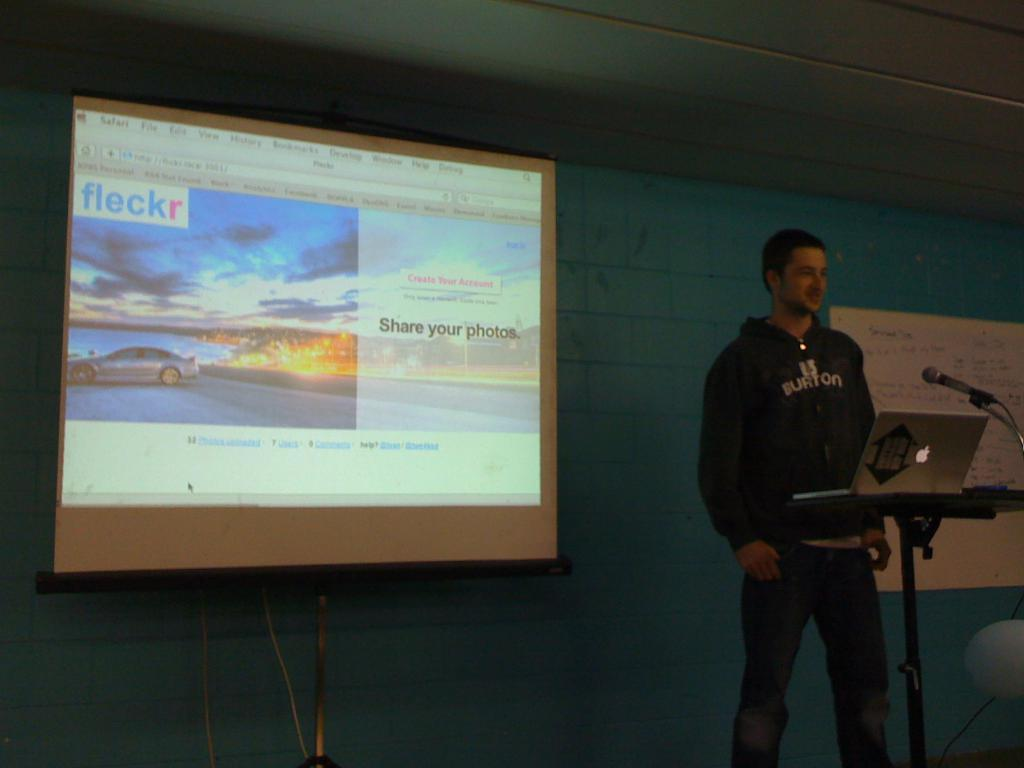<image>
Create a compact narrative representing the image presented. a screen that says share your photos on it 